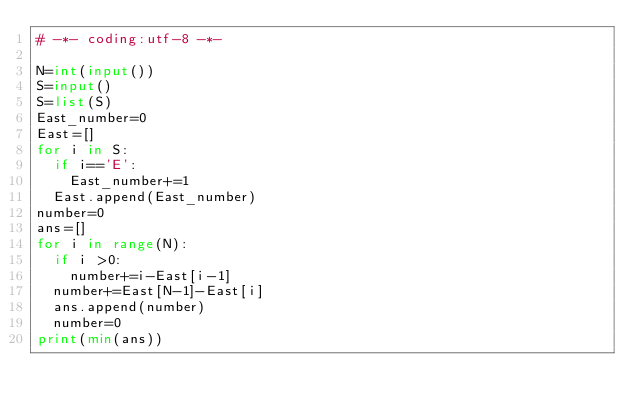Convert code to text. <code><loc_0><loc_0><loc_500><loc_500><_Python_># -*- coding:utf-8 -*-

N=int(input())
S=input()
S=list(S)
East_number=0
East=[]
for i in S:
  if i=='E':
    East_number+=1
  East.append(East_number)
number=0
ans=[]
for i in range(N):
  if i >0:
    number+=i-East[i-1]
  number+=East[N-1]-East[i]
  ans.append(number)
  number=0
print(min(ans))</code> 